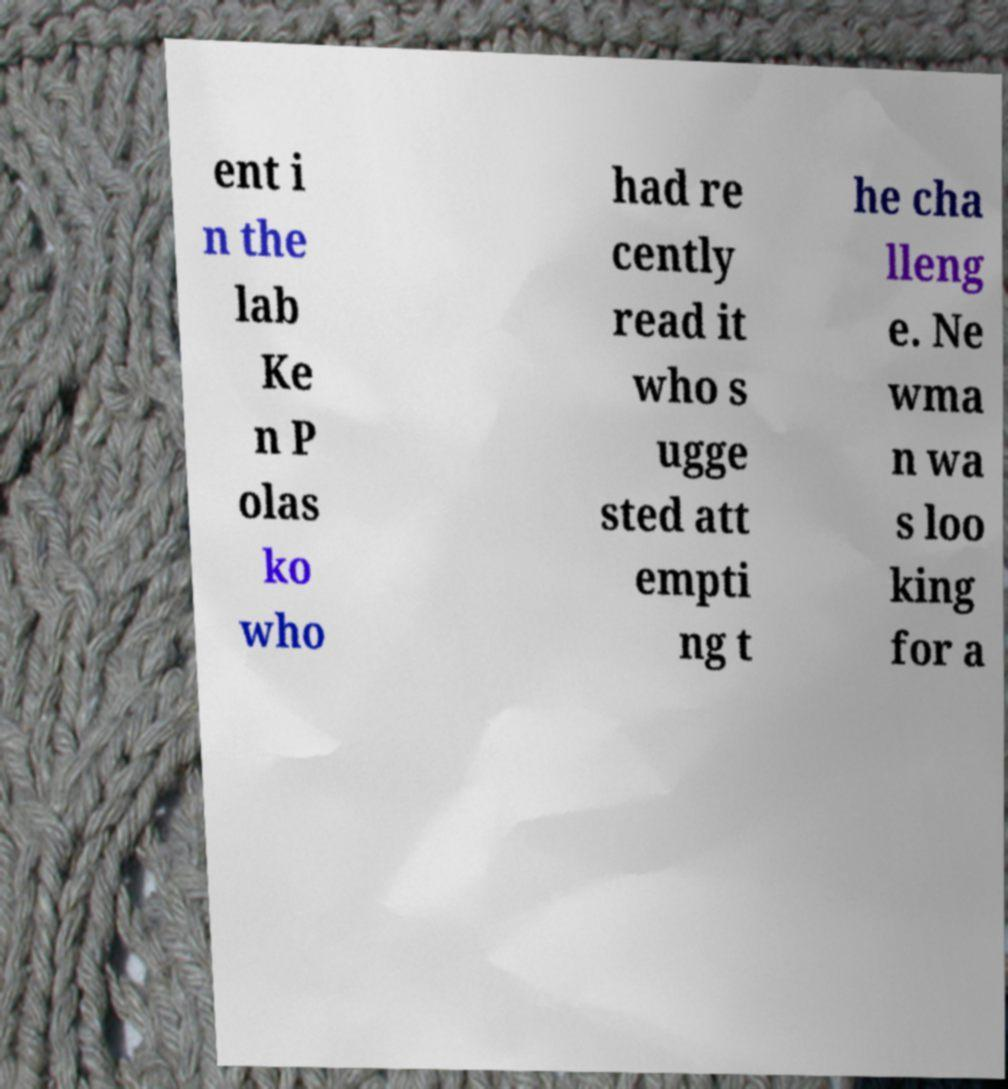Please read and relay the text visible in this image. What does it say? ent i n the lab Ke n P olas ko who had re cently read it who s ugge sted att empti ng t he cha lleng e. Ne wma n wa s loo king for a 